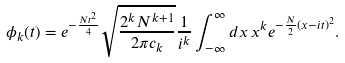Convert formula to latex. <formula><loc_0><loc_0><loc_500><loc_500>\phi _ { k } ( t ) = e ^ { - \frac { N t ^ { 2 } } { 4 } } \sqrt { \frac { 2 ^ { k } N ^ { k + 1 } } { 2 \pi c _ { k } } } \frac { 1 } { i ^ { k } } \int _ { - \infty } ^ { \infty } d x \, x ^ { k } e ^ { - \frac { N } { 2 } ( x - i t ) ^ { 2 } } .</formula> 